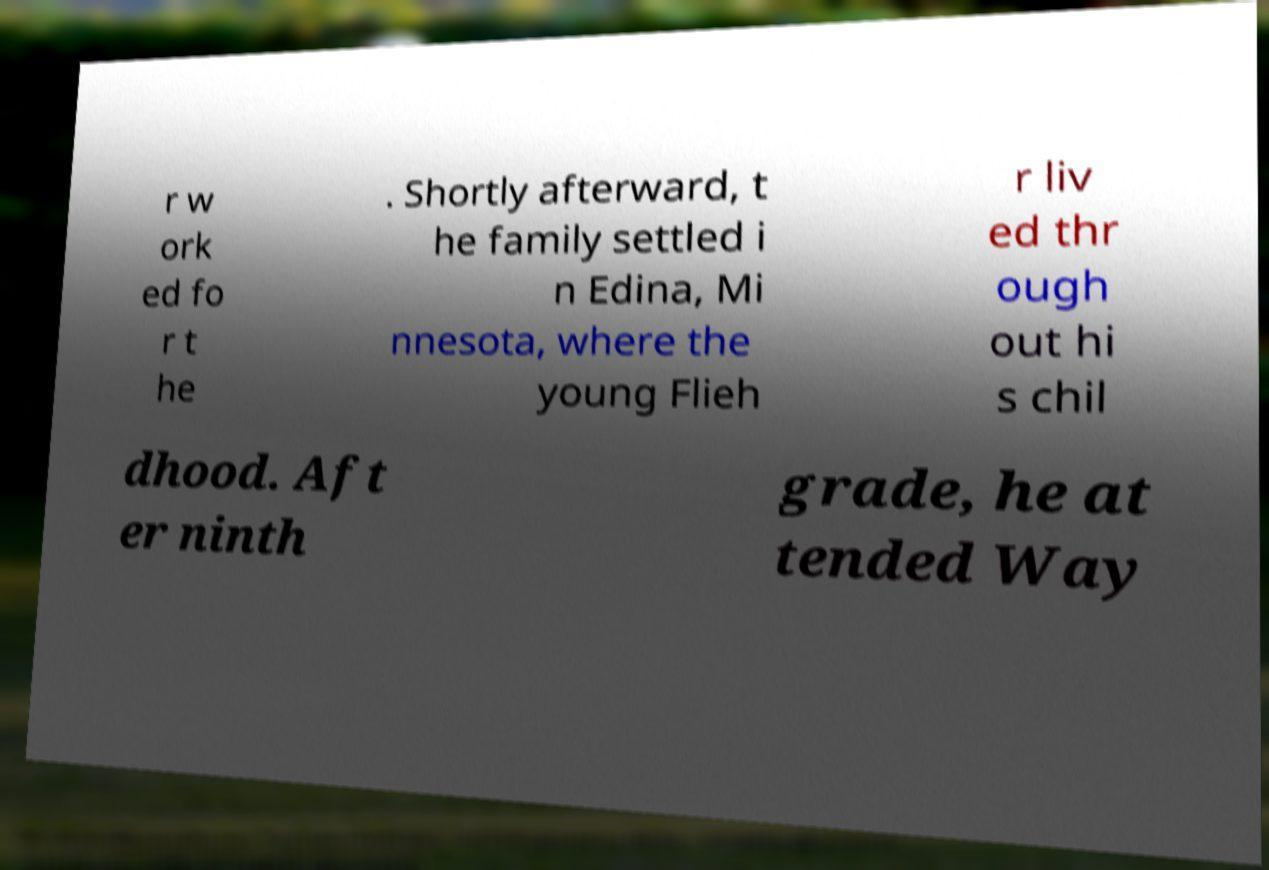Can you read and provide the text displayed in the image?This photo seems to have some interesting text. Can you extract and type it out for me? r w ork ed fo r t he . Shortly afterward, t he family settled i n Edina, Mi nnesota, where the young Flieh r liv ed thr ough out hi s chil dhood. Aft er ninth grade, he at tended Way 